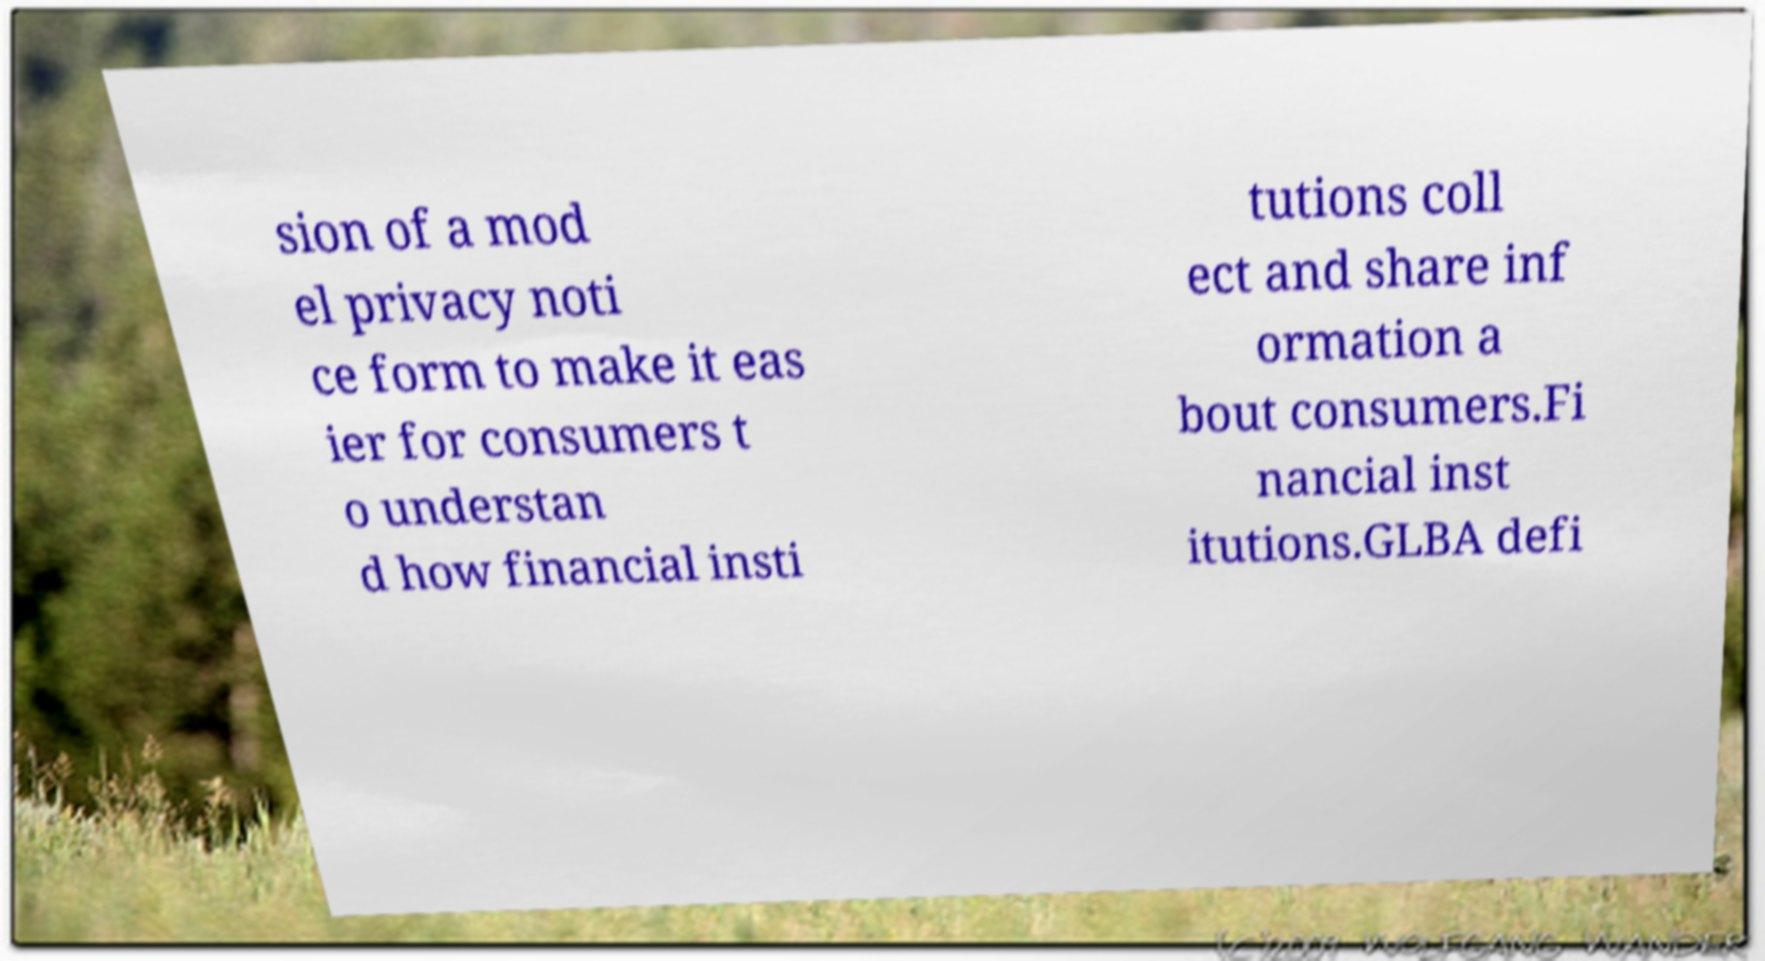Can you accurately transcribe the text from the provided image for me? sion of a mod el privacy noti ce form to make it eas ier for consumers t o understan d how financial insti tutions coll ect and share inf ormation a bout consumers.Fi nancial inst itutions.GLBA defi 